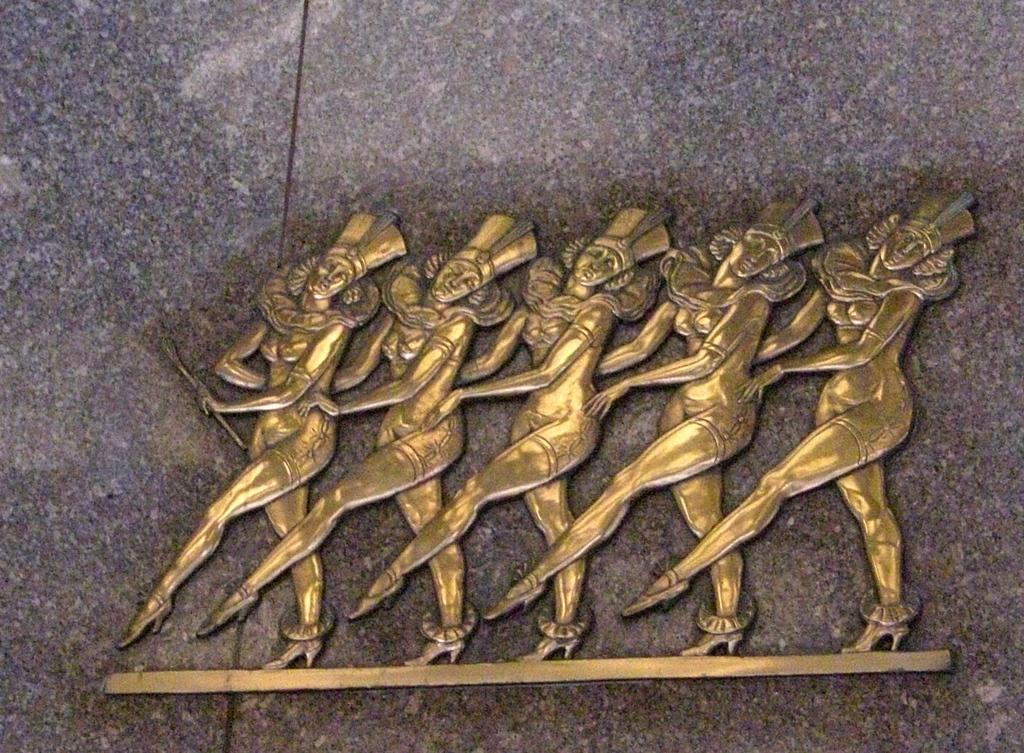What is the main subject of the image? The main subject of the image is a statue. What does the statue depict? The statue depicts five women. Where is the statue located in the image? The statue is placed on a surface. What type of hat is the woman in the statue wearing? There is no woman wearing a hat in the image, as the main subject is a statue depicting five women. 